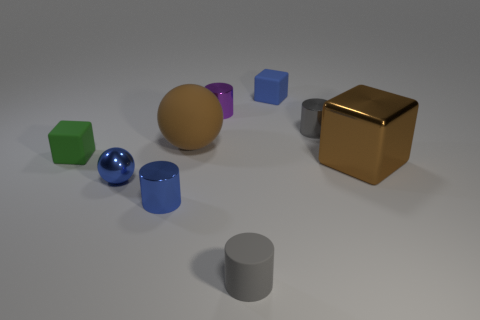What is the shape of the brown thing on the left side of the large thing in front of the small cube to the left of the tiny purple metal cylinder?
Your answer should be very brief. Sphere. There is a small block that is to the left of the small purple metallic object; how many objects are on the right side of it?
Give a very brief answer. 8. Do the blue cube and the tiny ball have the same material?
Ensure brevity in your answer.  No. There is a small block that is left of the tiny matte cube that is behind the big brown sphere; how many green rubber objects are on the left side of it?
Make the answer very short. 0. What is the color of the small block right of the blue ball?
Your answer should be compact. Blue. What is the shape of the rubber thing in front of the shiny thing that is in front of the tiny sphere?
Offer a terse response. Cylinder. Does the big shiny block have the same color as the big matte sphere?
Your response must be concise. Yes. What number of cubes are tiny green rubber things or blue things?
Provide a short and direct response. 2. The small cylinder that is to the left of the tiny blue rubber cube and behind the tiny sphere is made of what material?
Your answer should be compact. Metal. How many large matte spheres are left of the big ball?
Offer a very short reply. 0. 